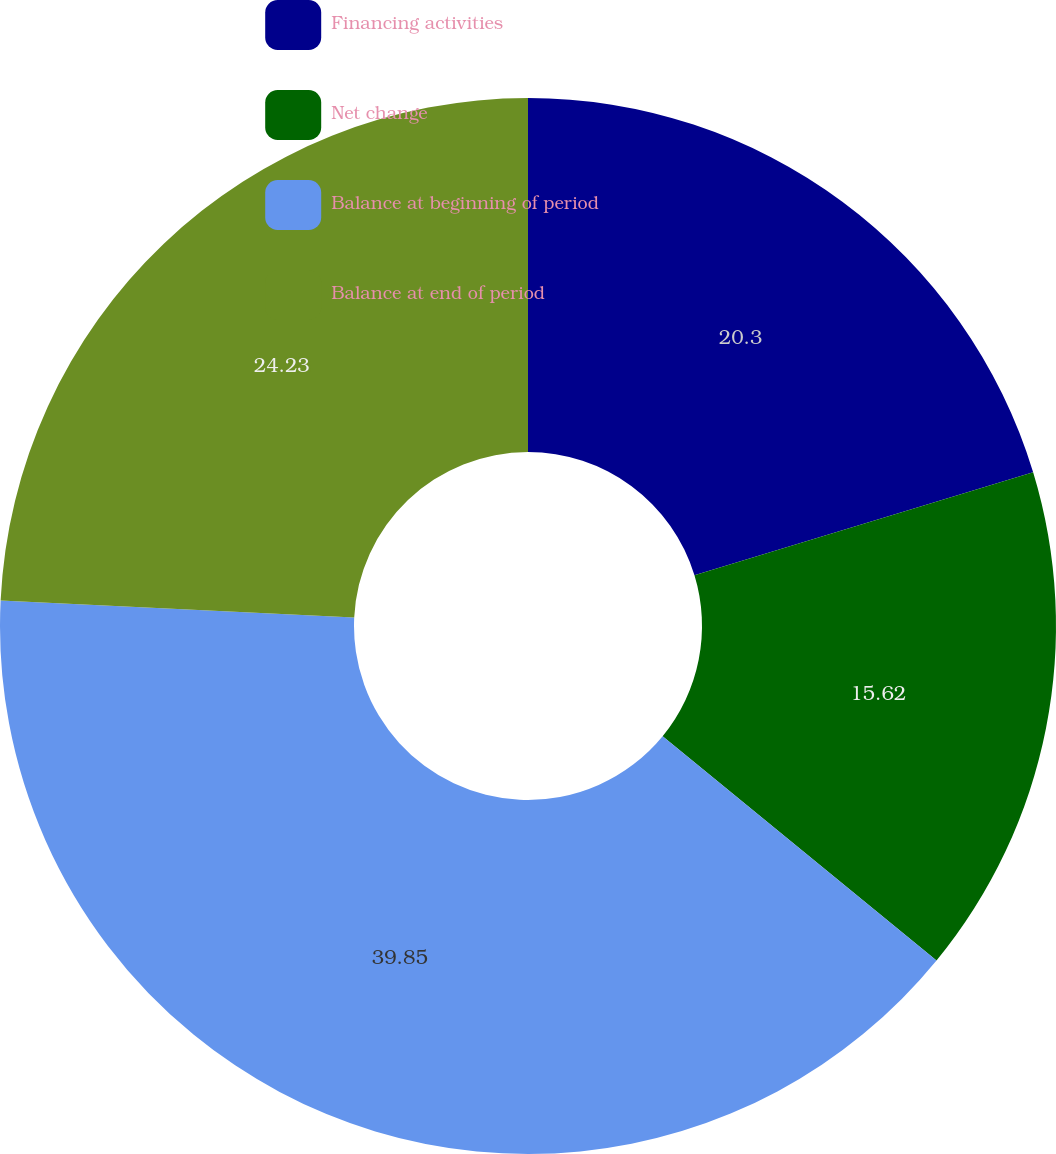<chart> <loc_0><loc_0><loc_500><loc_500><pie_chart><fcel>Financing activities<fcel>Net change<fcel>Balance at beginning of period<fcel>Balance at end of period<nl><fcel>20.3%<fcel>15.62%<fcel>39.85%<fcel>24.23%<nl></chart> 